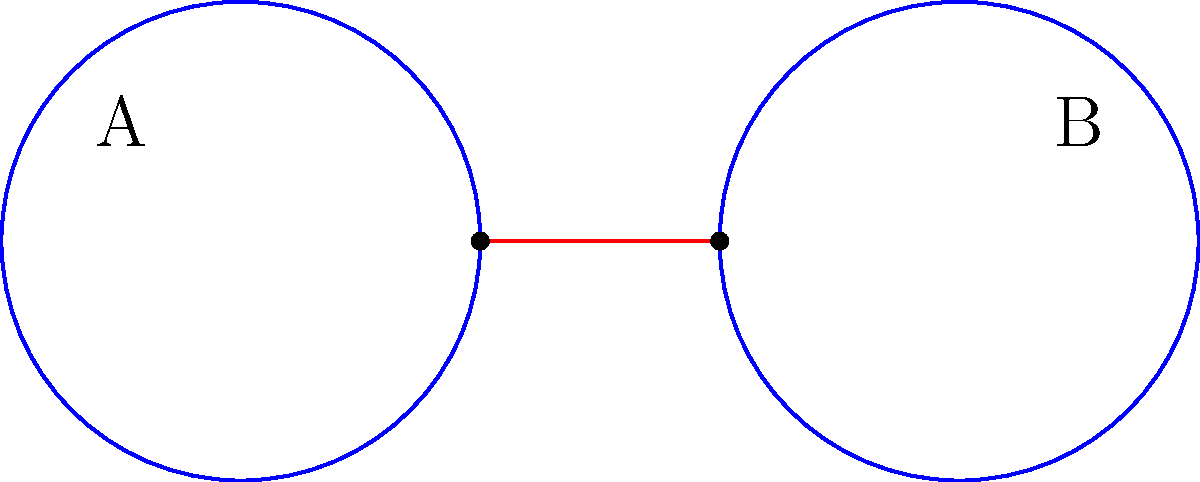Consider two Cuban islands represented by circles A and B, connected by a narrow land bridge. If the sea level rises, submerging the bridge, how does this affect the topological connectedness of the landscape? What minimum number of components would the resulting space have? To answer this question, we need to consider the concept of connectedness in topology:

1. Initially, the two islands (A and B) are connected by the land bridge, forming a single connected component.

2. In topology, a space is connected if it cannot be represented as the union of two or more disjoint non-empty open sets.

3. When the sea level rises and submerges the bridge:
   a. The connection between A and B is lost.
   b. Each island becomes a separate connected component.

4. In topological terms, the space is now disconnected, as it can be represented as the union of two disjoint non-empty open sets (the two islands).

5. The minimum number of components in the resulting space is determined by counting the number of disconnected parts:
   - Island A forms one component
   - Island B forms another component

6. Therefore, the minimum number of components in the resulting space is 2.

This scenario reflects the importance of geographical connections in Cuban landscapes and how environmental changes can affect the topology of a region.
Answer: 2 components 